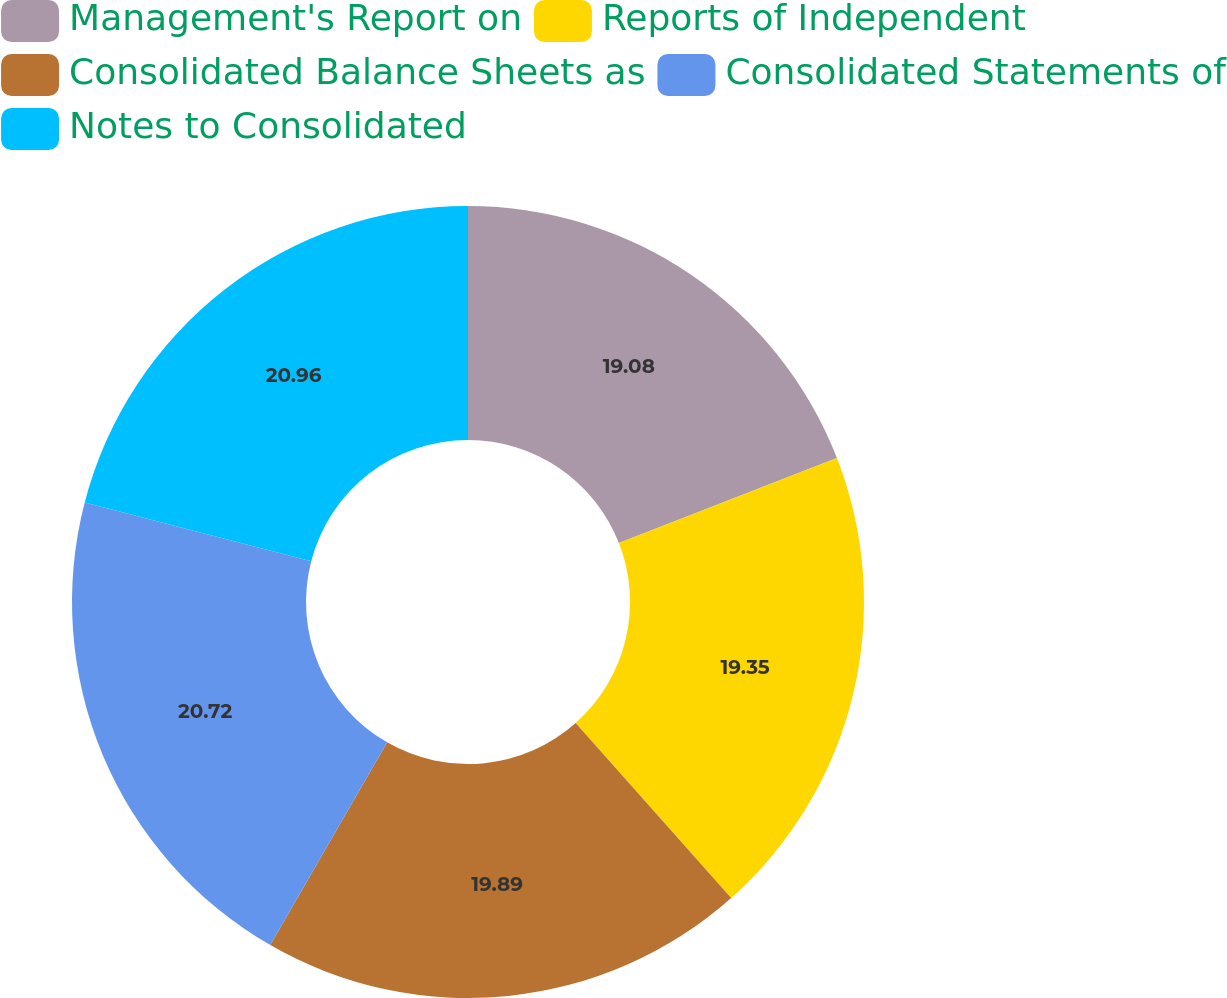Convert chart to OTSL. <chart><loc_0><loc_0><loc_500><loc_500><pie_chart><fcel>Management's Report on<fcel>Reports of Independent<fcel>Consolidated Balance Sheets as<fcel>Consolidated Statements of<fcel>Notes to Consolidated<nl><fcel>19.08%<fcel>19.35%<fcel>19.89%<fcel>20.72%<fcel>20.96%<nl></chart> 